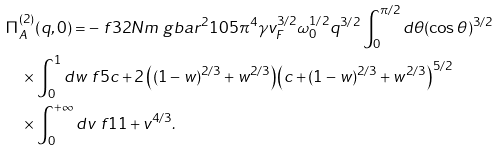<formula> <loc_0><loc_0><loc_500><loc_500>& \Pi _ { A } ^ { ( 2 ) } ( q , 0 ) = - \ f { 3 2 N m \ g b a r ^ { 2 } } { 1 0 5 \pi ^ { 4 } \gamma v _ { F } ^ { 3 / 2 } \omega _ { 0 } ^ { 1 / 2 } } q ^ { 3 / 2 } \int _ { 0 } ^ { \pi / 2 } d \theta ( \cos \theta ) ^ { 3 / 2 } \\ & \quad \times \int _ { 0 } ^ { 1 } d w \ f { 5 c + 2 \left ( ( 1 - w ) ^ { 2 / 3 } + w ^ { 2 / 3 } \right ) } { \left ( c + ( 1 - w ) ^ { 2 / 3 } + w ^ { 2 / 3 } \right ) ^ { 5 / 2 } } \\ & \quad \times \int _ { 0 } ^ { + \infty } d v \ f { 1 } { 1 + v ^ { 4 / 3 } } .</formula> 